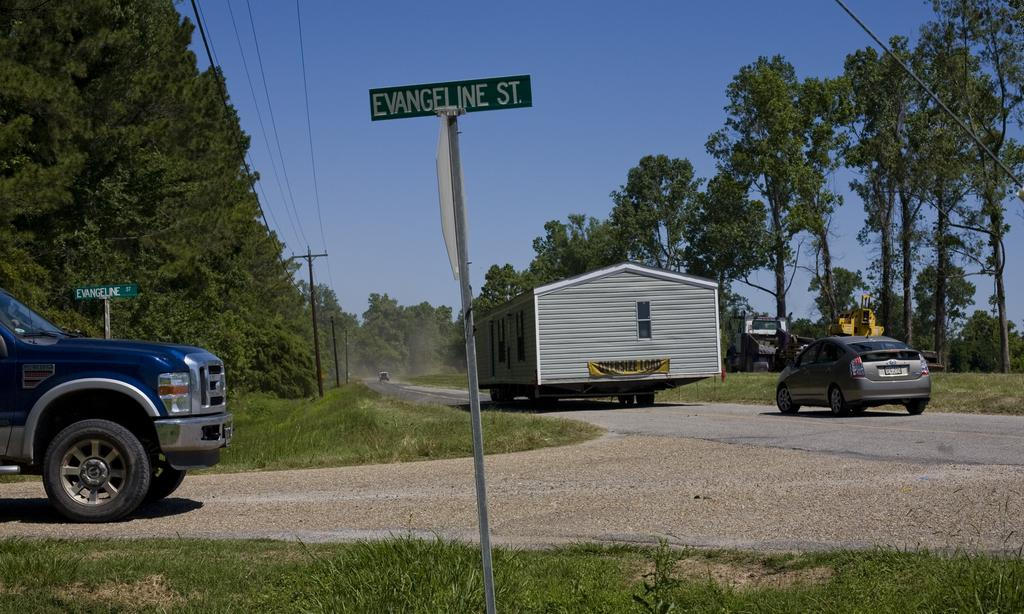What is located in the foreground of the image? There is a sign board in the foreground of the image. What can be seen on the right side of the image? There is a car on the right side of the image. Where is the car situated? The car is on a road. What type of natural environment is visible in the image? There are many trees visible in the image. What is visible in the background of the image? The sky is visible in the background of the image. What type of face can be seen on the calendar in the image? There is no calendar present in the image, so it is not possible to determine if there is a face on it. 